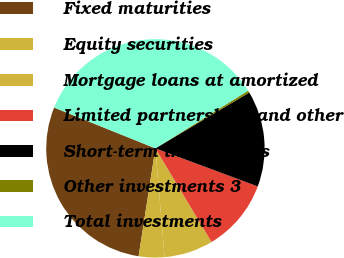Convert chart to OTSL. <chart><loc_0><loc_0><loc_500><loc_500><pie_chart><fcel>Fixed maturities<fcel>Equity securities<fcel>Mortgage loans at amortized<fcel>Limited partnerships and other<fcel>Short-term investments<fcel>Other investments 3<fcel>Total investments<nl><fcel>28.64%<fcel>3.79%<fcel>7.26%<fcel>10.74%<fcel>14.21%<fcel>0.32%<fcel>35.05%<nl></chart> 